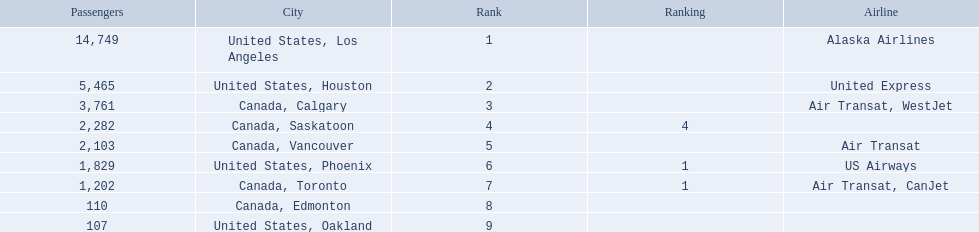What cities do the planes fly to? United States, Los Angeles, United States, Houston, Canada, Calgary, Canada, Saskatoon, Canada, Vancouver, United States, Phoenix, Canada, Toronto, Canada, Edmonton, United States, Oakland. How many people are flying to phoenix, arizona? 1,829. 